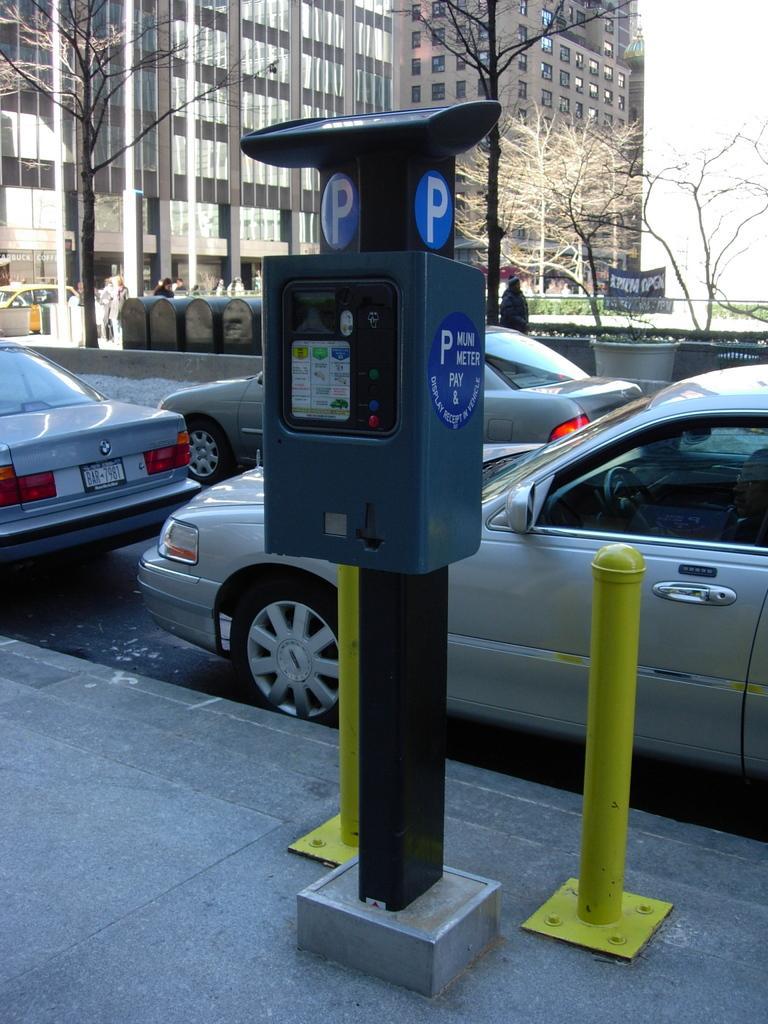How would you summarize this image in a sentence or two? In the foreground of the picture we can see poles, a box and footpath. In the middle of the picture there are cars, road and a person walking. In the background there are trees, people, car, buildings, banner, plants, sky and various objects. 